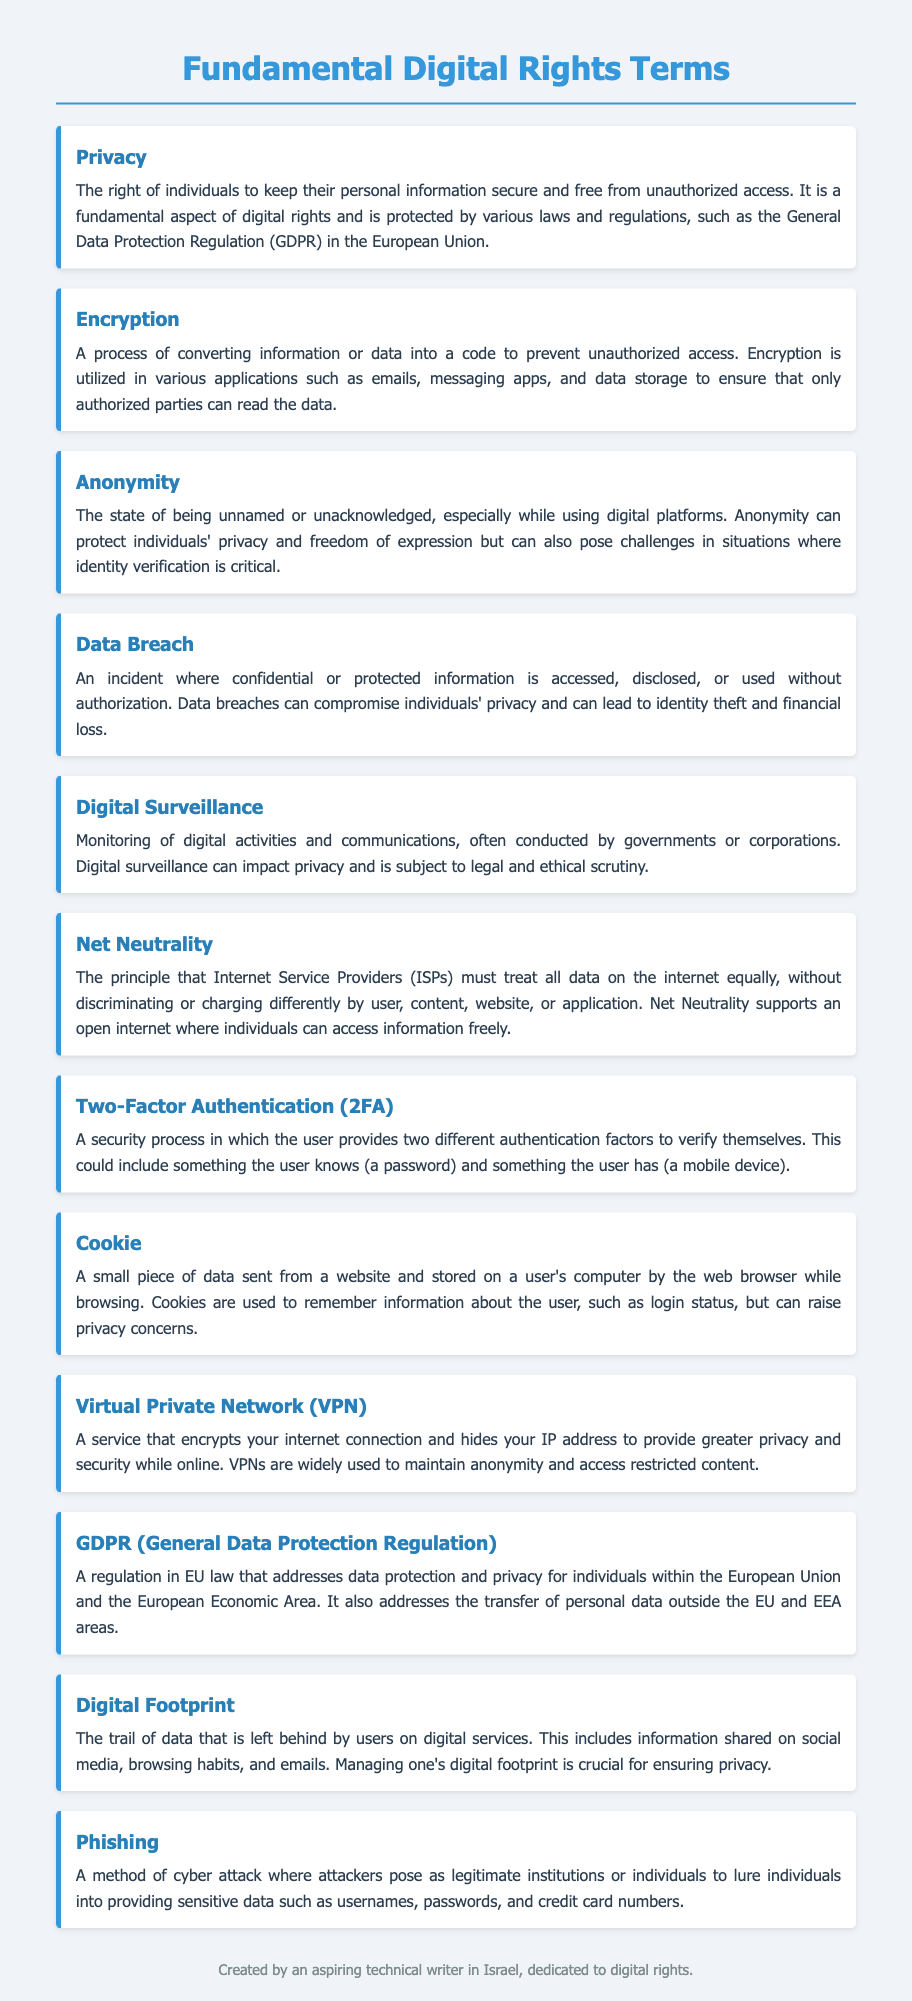What is the definition of Privacy? Privacy is defined as the right of individuals to keep their personal information secure and free from unauthorized access.
Answer: The right of individuals to keep their personal information secure and free from unauthorized access What does Encryption prevent? Encryption is a process that prevents unauthorized access to information or data.
Answer: Unauthorized access What is the principle of Net Neutrality? Net Neutrality states that Internet Service Providers must treat all data on the internet equally without discrimination.
Answer: Treat all data equally What is a Data Breach? A Data Breach is an incident where confidential information is accessed or used without authorization.
Answer: Accessed or used without authorization What does GDPR stand for? GDPR stands for General Data Protection Regulation.
Answer: General Data Protection Regulation What is one use of a Virtual Private Network (VPN)? A VPN is used to encrypt internet connections to provide greater privacy and security.
Answer: Encrypt internet connections What does Digital Surveillance involve? Digital Surveillance involves monitoring of digital activities and communications.
Answer: Monitoring of digital activities and communications How does Two-Factor Authentication (2FA) enhance security? 2FA enhances security by requiring two different authentication factors from the user.
Answer: Requires two different authentication factors What is a Cookie in digital terms? A Cookie is a small piece of data sent from a website and stored on a user's computer.
Answer: A small piece of data 